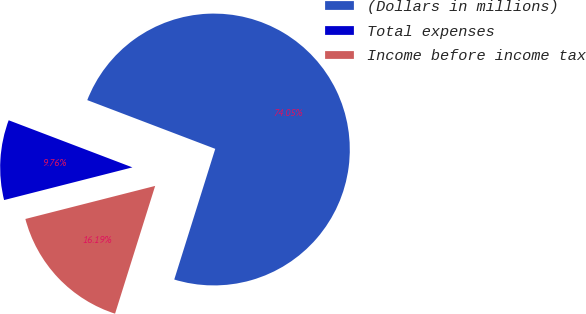Convert chart to OTSL. <chart><loc_0><loc_0><loc_500><loc_500><pie_chart><fcel>(Dollars in millions)<fcel>Total expenses<fcel>Income before income tax<nl><fcel>74.04%<fcel>9.76%<fcel>16.19%<nl></chart> 